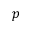Convert formula to latex. <formula><loc_0><loc_0><loc_500><loc_500>p</formula> 